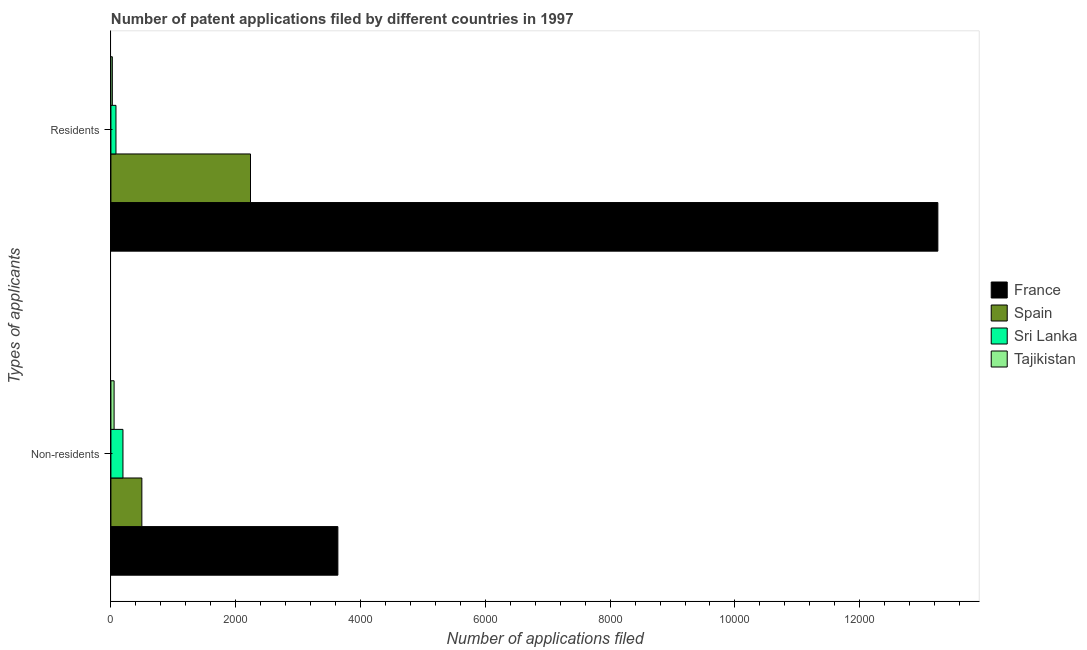How many different coloured bars are there?
Your answer should be compact. 4. How many groups of bars are there?
Your answer should be compact. 2. Are the number of bars on each tick of the Y-axis equal?
Your answer should be compact. Yes. How many bars are there on the 1st tick from the bottom?
Offer a terse response. 4. What is the label of the 1st group of bars from the top?
Provide a succinct answer. Residents. What is the number of patent applications by non residents in France?
Make the answer very short. 3637. Across all countries, what is the maximum number of patent applications by residents?
Your response must be concise. 1.33e+04. Across all countries, what is the minimum number of patent applications by residents?
Keep it short and to the point. 23. In which country was the number of patent applications by non residents minimum?
Keep it short and to the point. Tajikistan. What is the total number of patent applications by non residents in the graph?
Your answer should be very brief. 4377. What is the difference between the number of patent applications by non residents in France and that in Tajikistan?
Provide a succinct answer. 3586. What is the difference between the number of patent applications by residents in Sri Lanka and the number of patent applications by non residents in Spain?
Make the answer very short. -415. What is the average number of patent applications by non residents per country?
Ensure brevity in your answer.  1094.25. What is the difference between the number of patent applications by residents and number of patent applications by non residents in Tajikistan?
Provide a short and direct response. -28. In how many countries, is the number of patent applications by residents greater than 8400 ?
Offer a very short reply. 1. What is the ratio of the number of patent applications by non residents in Tajikistan to that in Spain?
Give a very brief answer. 0.1. Is the number of patent applications by residents in France less than that in Tajikistan?
Give a very brief answer. No. In how many countries, is the number of patent applications by residents greater than the average number of patent applications by residents taken over all countries?
Make the answer very short. 1. What does the 1st bar from the top in Non-residents represents?
Keep it short and to the point. Tajikistan. What does the 3rd bar from the bottom in Residents represents?
Provide a succinct answer. Sri Lanka. How many bars are there?
Make the answer very short. 8. Are the values on the major ticks of X-axis written in scientific E-notation?
Provide a succinct answer. No. Does the graph contain any zero values?
Offer a very short reply. No. Does the graph contain grids?
Provide a succinct answer. No. How many legend labels are there?
Keep it short and to the point. 4. What is the title of the graph?
Your answer should be compact. Number of patent applications filed by different countries in 1997. Does "Korea (Democratic)" appear as one of the legend labels in the graph?
Offer a very short reply. No. What is the label or title of the X-axis?
Ensure brevity in your answer.  Number of applications filed. What is the label or title of the Y-axis?
Ensure brevity in your answer.  Types of applicants. What is the Number of applications filed in France in Non-residents?
Provide a succinct answer. 3637. What is the Number of applications filed of Spain in Non-residents?
Give a very brief answer. 496. What is the Number of applications filed of Sri Lanka in Non-residents?
Your response must be concise. 193. What is the Number of applications filed in Tajikistan in Non-residents?
Give a very brief answer. 51. What is the Number of applications filed of France in Residents?
Provide a succinct answer. 1.33e+04. What is the Number of applications filed in Spain in Residents?
Offer a very short reply. 2237. Across all Types of applicants, what is the maximum Number of applications filed of France?
Your answer should be compact. 1.33e+04. Across all Types of applicants, what is the maximum Number of applications filed of Spain?
Offer a very short reply. 2237. Across all Types of applicants, what is the maximum Number of applications filed in Sri Lanka?
Make the answer very short. 193. Across all Types of applicants, what is the maximum Number of applications filed in Tajikistan?
Ensure brevity in your answer.  51. Across all Types of applicants, what is the minimum Number of applications filed of France?
Offer a very short reply. 3637. Across all Types of applicants, what is the minimum Number of applications filed of Spain?
Make the answer very short. 496. Across all Types of applicants, what is the minimum Number of applications filed in Sri Lanka?
Your answer should be very brief. 81. What is the total Number of applications filed of France in the graph?
Provide a succinct answer. 1.69e+04. What is the total Number of applications filed of Spain in the graph?
Your answer should be compact. 2733. What is the total Number of applications filed in Sri Lanka in the graph?
Make the answer very short. 274. What is the total Number of applications filed of Tajikistan in the graph?
Keep it short and to the point. 74. What is the difference between the Number of applications filed in France in Non-residents and that in Residents?
Keep it short and to the point. -9615. What is the difference between the Number of applications filed of Spain in Non-residents and that in Residents?
Provide a succinct answer. -1741. What is the difference between the Number of applications filed of Sri Lanka in Non-residents and that in Residents?
Ensure brevity in your answer.  112. What is the difference between the Number of applications filed of France in Non-residents and the Number of applications filed of Spain in Residents?
Provide a short and direct response. 1400. What is the difference between the Number of applications filed of France in Non-residents and the Number of applications filed of Sri Lanka in Residents?
Your answer should be compact. 3556. What is the difference between the Number of applications filed in France in Non-residents and the Number of applications filed in Tajikistan in Residents?
Provide a succinct answer. 3614. What is the difference between the Number of applications filed of Spain in Non-residents and the Number of applications filed of Sri Lanka in Residents?
Offer a terse response. 415. What is the difference between the Number of applications filed in Spain in Non-residents and the Number of applications filed in Tajikistan in Residents?
Your answer should be very brief. 473. What is the difference between the Number of applications filed in Sri Lanka in Non-residents and the Number of applications filed in Tajikistan in Residents?
Your response must be concise. 170. What is the average Number of applications filed of France per Types of applicants?
Your response must be concise. 8444.5. What is the average Number of applications filed in Spain per Types of applicants?
Offer a terse response. 1366.5. What is the average Number of applications filed of Sri Lanka per Types of applicants?
Offer a terse response. 137. What is the average Number of applications filed of Tajikistan per Types of applicants?
Your answer should be compact. 37. What is the difference between the Number of applications filed of France and Number of applications filed of Spain in Non-residents?
Your response must be concise. 3141. What is the difference between the Number of applications filed in France and Number of applications filed in Sri Lanka in Non-residents?
Offer a very short reply. 3444. What is the difference between the Number of applications filed in France and Number of applications filed in Tajikistan in Non-residents?
Offer a very short reply. 3586. What is the difference between the Number of applications filed of Spain and Number of applications filed of Sri Lanka in Non-residents?
Offer a terse response. 303. What is the difference between the Number of applications filed of Spain and Number of applications filed of Tajikistan in Non-residents?
Ensure brevity in your answer.  445. What is the difference between the Number of applications filed in Sri Lanka and Number of applications filed in Tajikistan in Non-residents?
Offer a very short reply. 142. What is the difference between the Number of applications filed of France and Number of applications filed of Spain in Residents?
Keep it short and to the point. 1.10e+04. What is the difference between the Number of applications filed in France and Number of applications filed in Sri Lanka in Residents?
Your answer should be very brief. 1.32e+04. What is the difference between the Number of applications filed of France and Number of applications filed of Tajikistan in Residents?
Provide a short and direct response. 1.32e+04. What is the difference between the Number of applications filed of Spain and Number of applications filed of Sri Lanka in Residents?
Give a very brief answer. 2156. What is the difference between the Number of applications filed of Spain and Number of applications filed of Tajikistan in Residents?
Provide a short and direct response. 2214. What is the ratio of the Number of applications filed of France in Non-residents to that in Residents?
Your response must be concise. 0.27. What is the ratio of the Number of applications filed in Spain in Non-residents to that in Residents?
Give a very brief answer. 0.22. What is the ratio of the Number of applications filed of Sri Lanka in Non-residents to that in Residents?
Keep it short and to the point. 2.38. What is the ratio of the Number of applications filed of Tajikistan in Non-residents to that in Residents?
Your response must be concise. 2.22. What is the difference between the highest and the second highest Number of applications filed in France?
Provide a short and direct response. 9615. What is the difference between the highest and the second highest Number of applications filed in Spain?
Keep it short and to the point. 1741. What is the difference between the highest and the second highest Number of applications filed in Sri Lanka?
Provide a short and direct response. 112. What is the difference between the highest and the lowest Number of applications filed of France?
Offer a very short reply. 9615. What is the difference between the highest and the lowest Number of applications filed in Spain?
Offer a very short reply. 1741. What is the difference between the highest and the lowest Number of applications filed in Sri Lanka?
Offer a very short reply. 112. What is the difference between the highest and the lowest Number of applications filed of Tajikistan?
Your answer should be very brief. 28. 